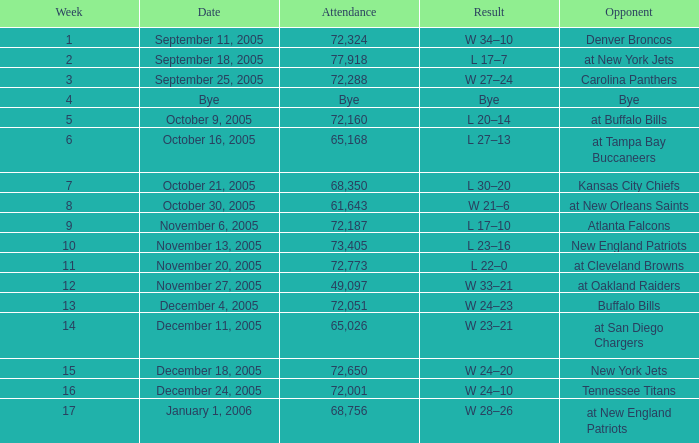On what Date was the Attendance 73,405? November 13, 2005. 